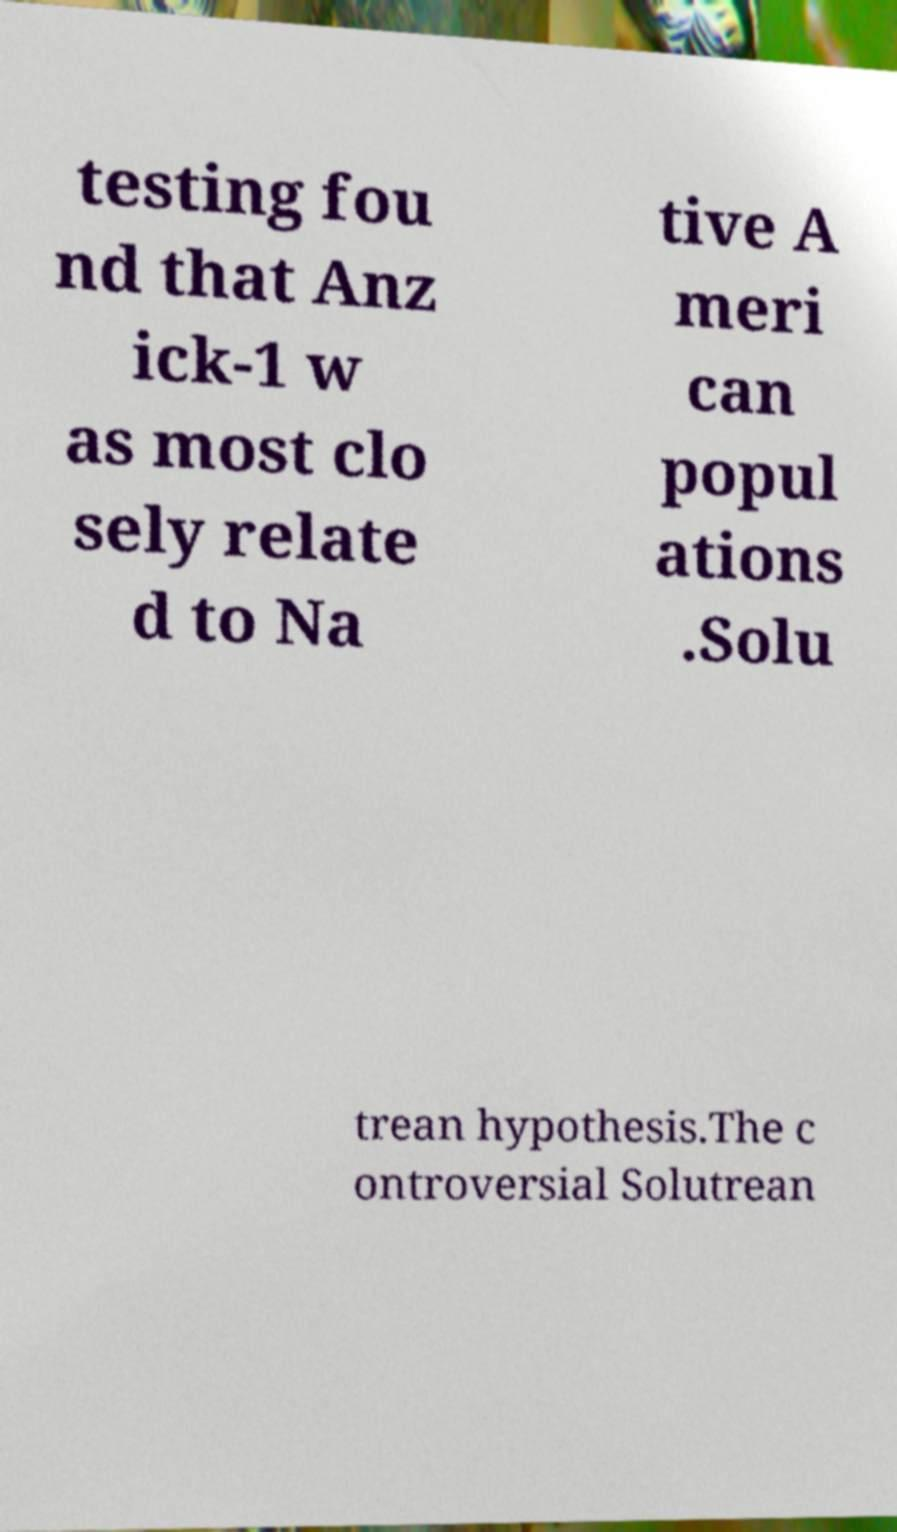Could you assist in decoding the text presented in this image and type it out clearly? testing fou nd that Anz ick-1 w as most clo sely relate d to Na tive A meri can popul ations .Solu trean hypothesis.The c ontroversial Solutrean 